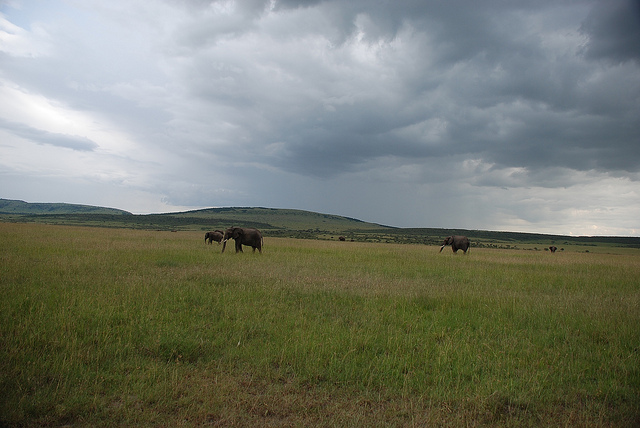<image>What color are the trees? There are no trees in the image. What images do you see in the clouds? It's ambiguous to identify specific images in the clouds. Some might perceive it as 'afro', 'dark balls', 'child looking up with glasses on', 'wispy', 'faces', 'cotton balls', or 'bird', however, some might not see anything specified. What color are the trees? The color of the trees is green. What images do you see in the clouds? I am not sure what images are seen in the clouds. It can be seen afro, cloud, dark balls, child looking up with glasses on, wispy faces, cotton balls, or bird. 